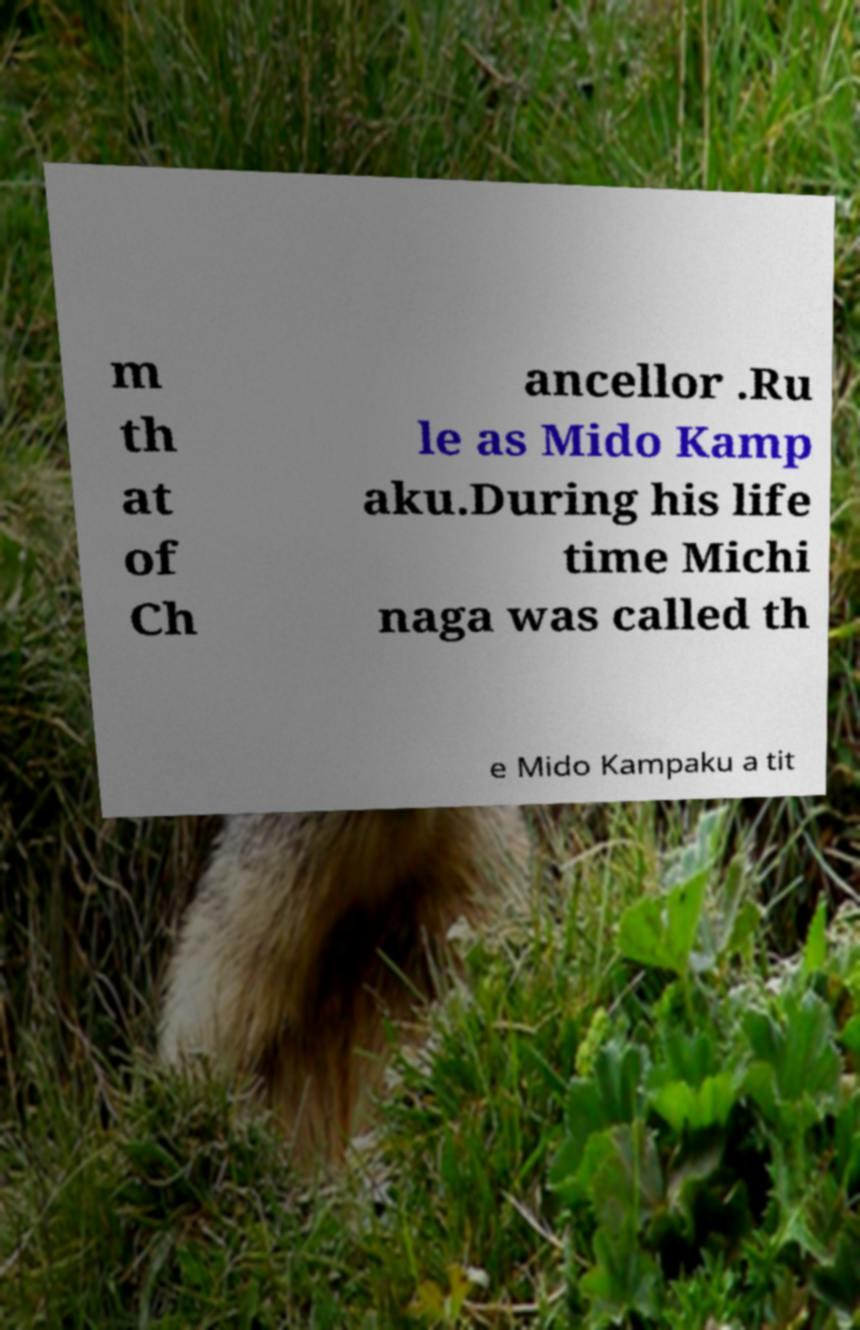What messages or text are displayed in this image? I need them in a readable, typed format. m th at of Ch ancellor .Ru le as Mido Kamp aku.During his life time Michi naga was called th e Mido Kampaku a tit 